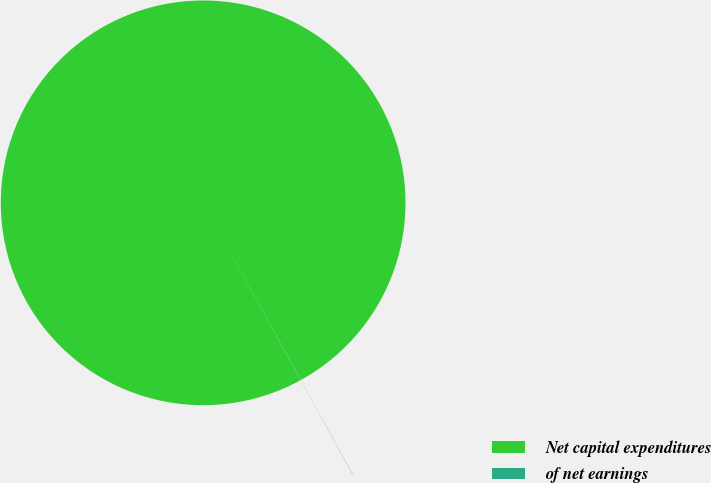<chart> <loc_0><loc_0><loc_500><loc_500><pie_chart><fcel>Net capital expenditures<fcel>of net earnings<nl><fcel>99.98%<fcel>0.02%<nl></chart> 